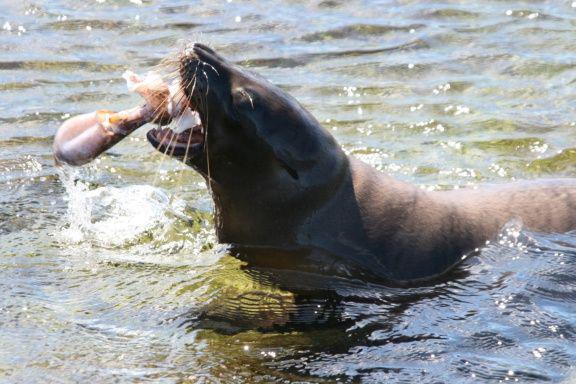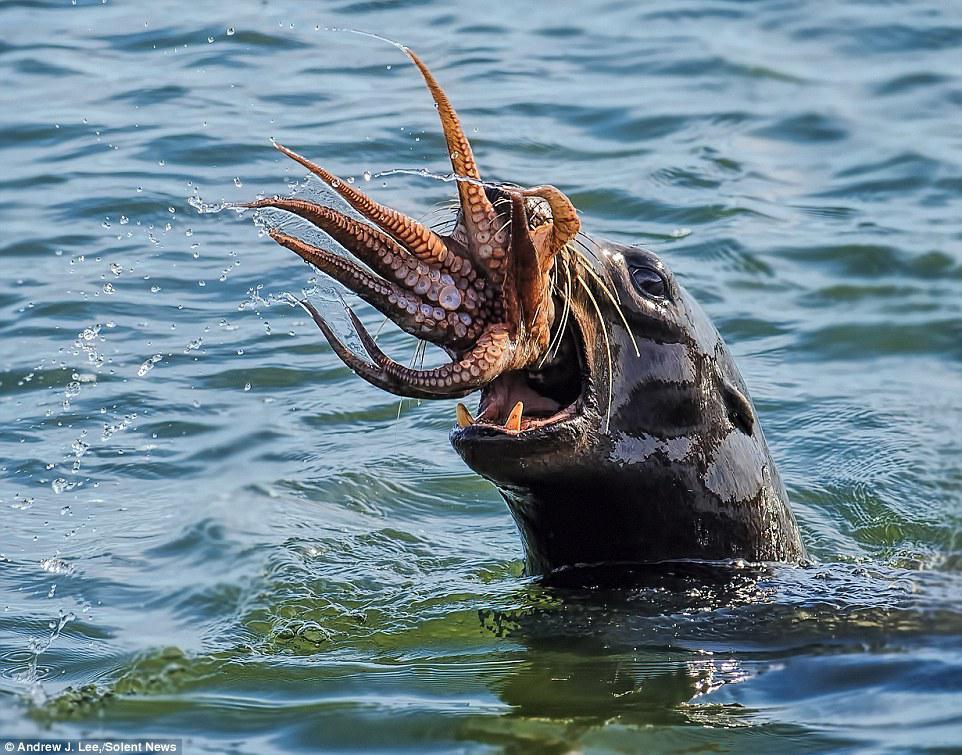The first image is the image on the left, the second image is the image on the right. Analyze the images presented: Is the assertion "The squid in in the wide open mouth of the seal in at least one of the images." valid? Answer yes or no. Yes. The first image is the image on the left, the second image is the image on the right. Given the left and right images, does the statement "Right image shows a seal with its head above water and octopus legs sticking out of its mouth." hold true? Answer yes or no. Yes. 